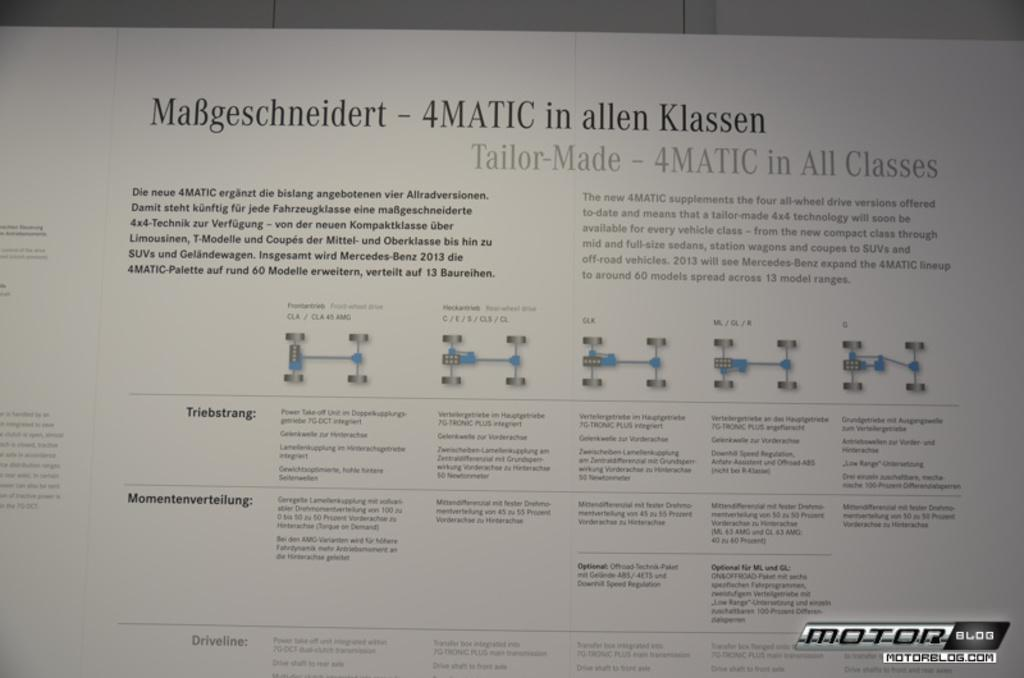<image>
Give a short and clear explanation of the subsequent image. A poster showing a car chassis says 4Matic in allen Klassen. 